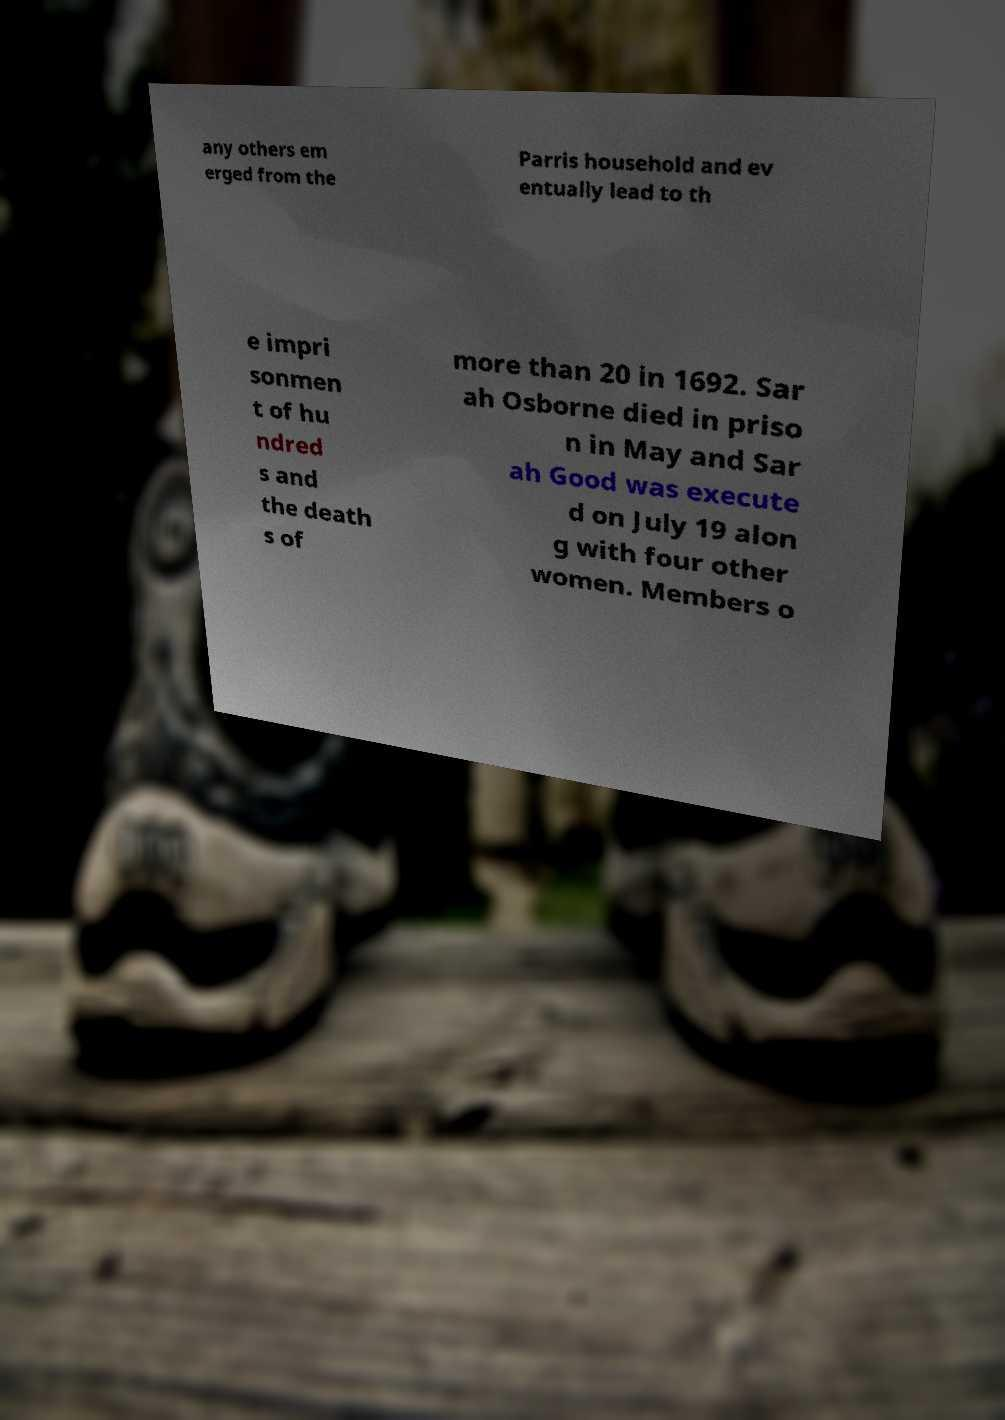For documentation purposes, I need the text within this image transcribed. Could you provide that? any others em erged from the Parris household and ev entually lead to th e impri sonmen t of hu ndred s and the death s of more than 20 in 1692. Sar ah Osborne died in priso n in May and Sar ah Good was execute d on July 19 alon g with four other women. Members o 